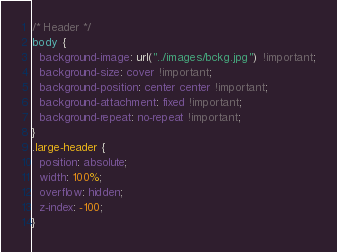Convert code to text. <code><loc_0><loc_0><loc_500><loc_500><_CSS_>/* Header */
body {
  background-image: url("../images/bckg.jpg") !important;
  background-size: cover !important;
  background-position: center center !important;
  background-attachment: fixed !important;
  background-repeat: no-repeat !important;
}
.large-header {
  position: absolute;
  width: 100%;
  overflow: hidden;
  z-index: -100;
}

</code> 